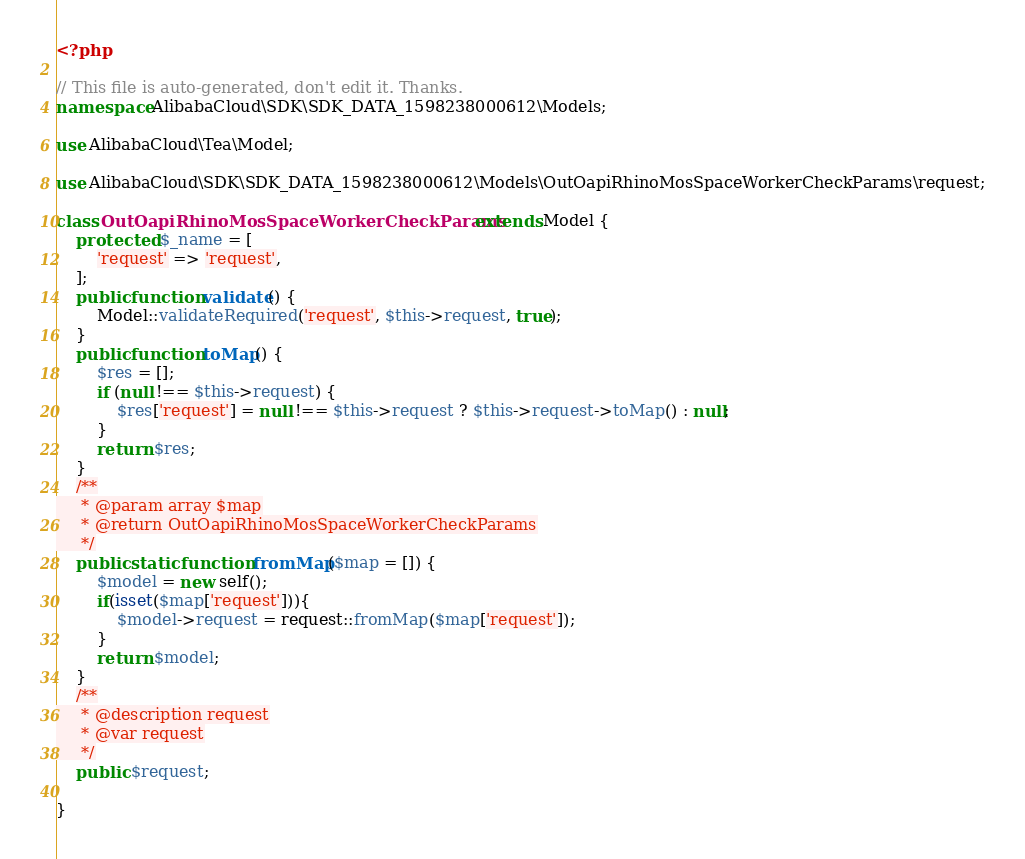<code> <loc_0><loc_0><loc_500><loc_500><_PHP_><?php

// This file is auto-generated, don't edit it. Thanks.
namespace AlibabaCloud\SDK\SDK_DATA_1598238000612\Models;

use AlibabaCloud\Tea\Model;

use AlibabaCloud\SDK\SDK_DATA_1598238000612\Models\OutOapiRhinoMosSpaceWorkerCheckParams\request;

class OutOapiRhinoMosSpaceWorkerCheckParams extends Model {
    protected $_name = [
        'request' => 'request',
    ];
    public function validate() {
        Model::validateRequired('request', $this->request, true);
    }
    public function toMap() {
        $res = [];
        if (null !== $this->request) {
            $res['request'] = null !== $this->request ? $this->request->toMap() : null;
        }
        return $res;
    }
    /**
     * @param array $map
     * @return OutOapiRhinoMosSpaceWorkerCheckParams
     */
    public static function fromMap($map = []) {
        $model = new self();
        if(isset($map['request'])){
            $model->request = request::fromMap($map['request']);
        }
        return $model;
    }
    /**
     * @description request
     * @var request
     */
    public $request;

}
</code> 